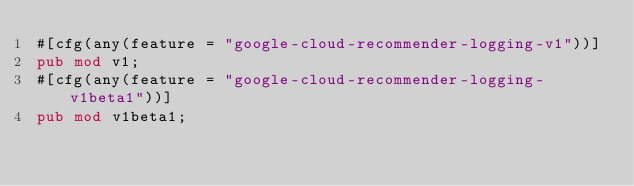Convert code to text. <code><loc_0><loc_0><loc_500><loc_500><_Rust_>#[cfg(any(feature = "google-cloud-recommender-logging-v1"))]
pub mod v1;
#[cfg(any(feature = "google-cloud-recommender-logging-v1beta1"))]
pub mod v1beta1;
</code> 